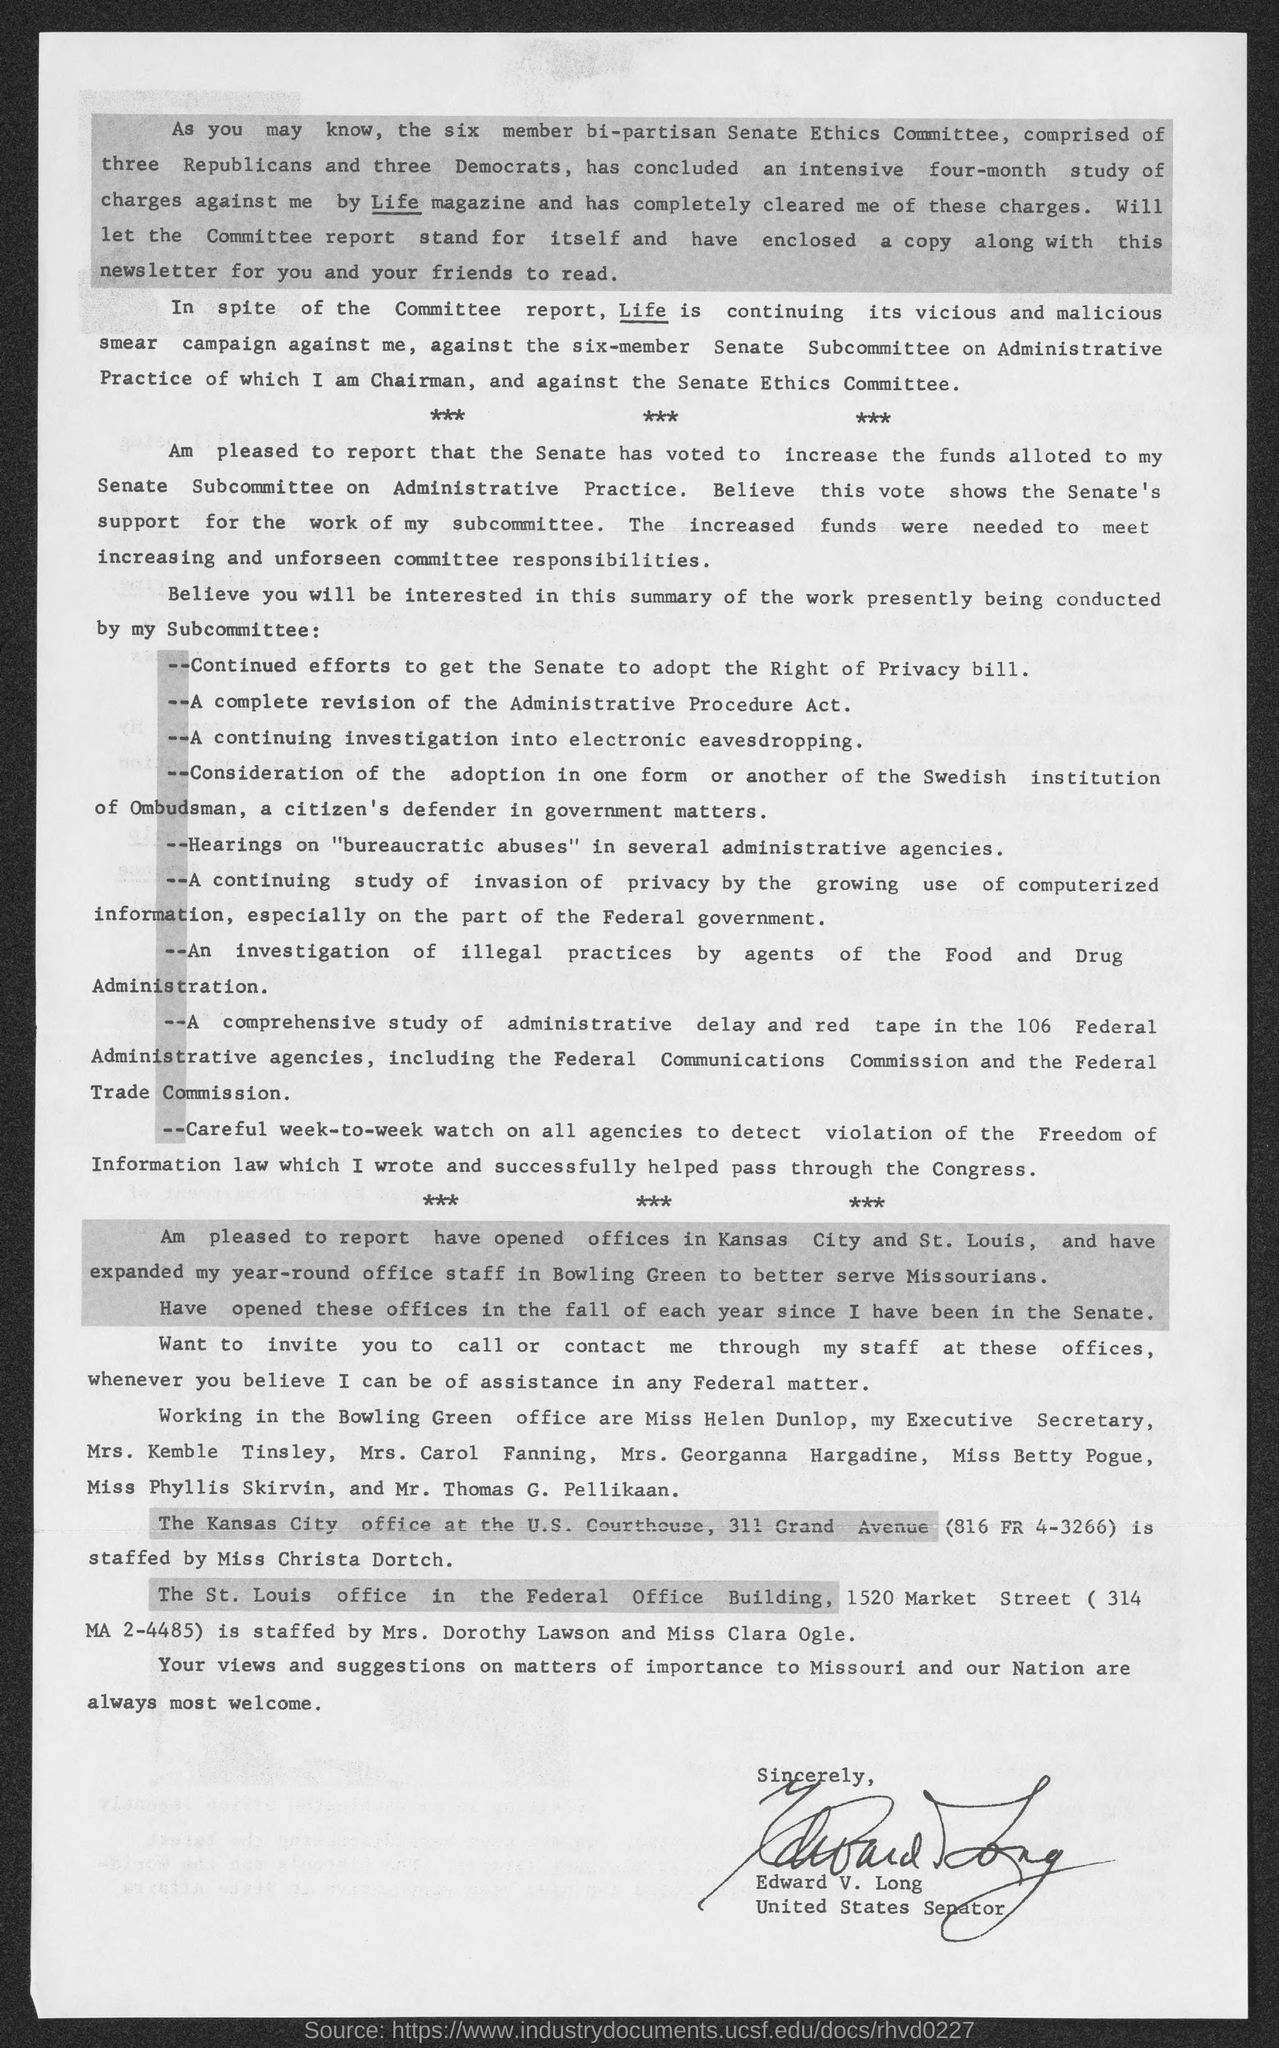Who is the united states senator?
Ensure brevity in your answer.  Edward V. Long. 